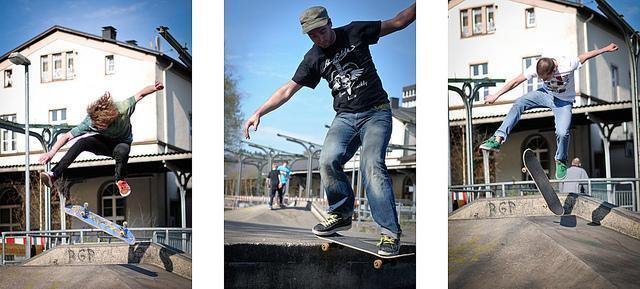How many people are there?
Give a very brief answer. 3. How many banana stems without bananas are there?
Give a very brief answer. 0. 